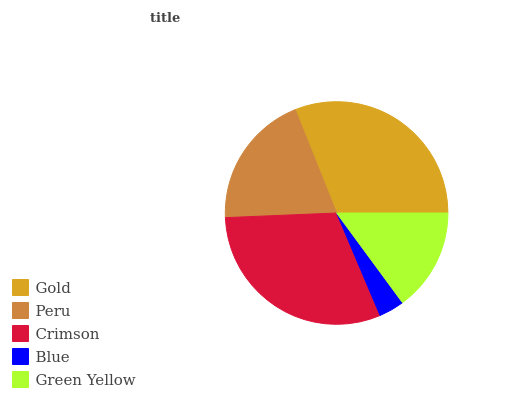Is Blue the minimum?
Answer yes or no. Yes. Is Gold the maximum?
Answer yes or no. Yes. Is Peru the minimum?
Answer yes or no. No. Is Peru the maximum?
Answer yes or no. No. Is Gold greater than Peru?
Answer yes or no. Yes. Is Peru less than Gold?
Answer yes or no. Yes. Is Peru greater than Gold?
Answer yes or no. No. Is Gold less than Peru?
Answer yes or no. No. Is Peru the high median?
Answer yes or no. Yes. Is Peru the low median?
Answer yes or no. Yes. Is Crimson the high median?
Answer yes or no. No. Is Gold the low median?
Answer yes or no. No. 